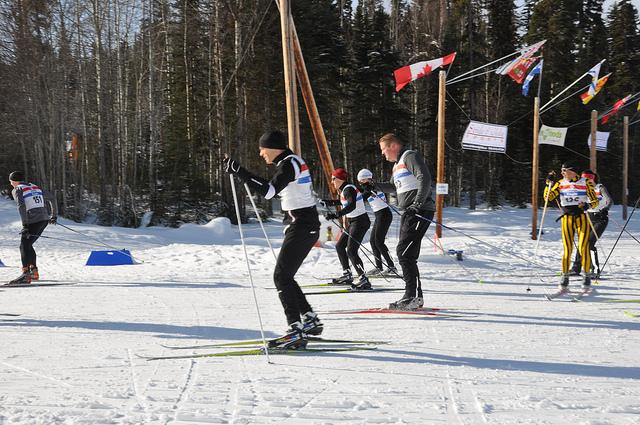Are they skiing?
Answer briefly. Yes. How many skiers are there?
Write a very short answer. 7. Which skier has the flashiest pants?
Quick response, please. Right. 